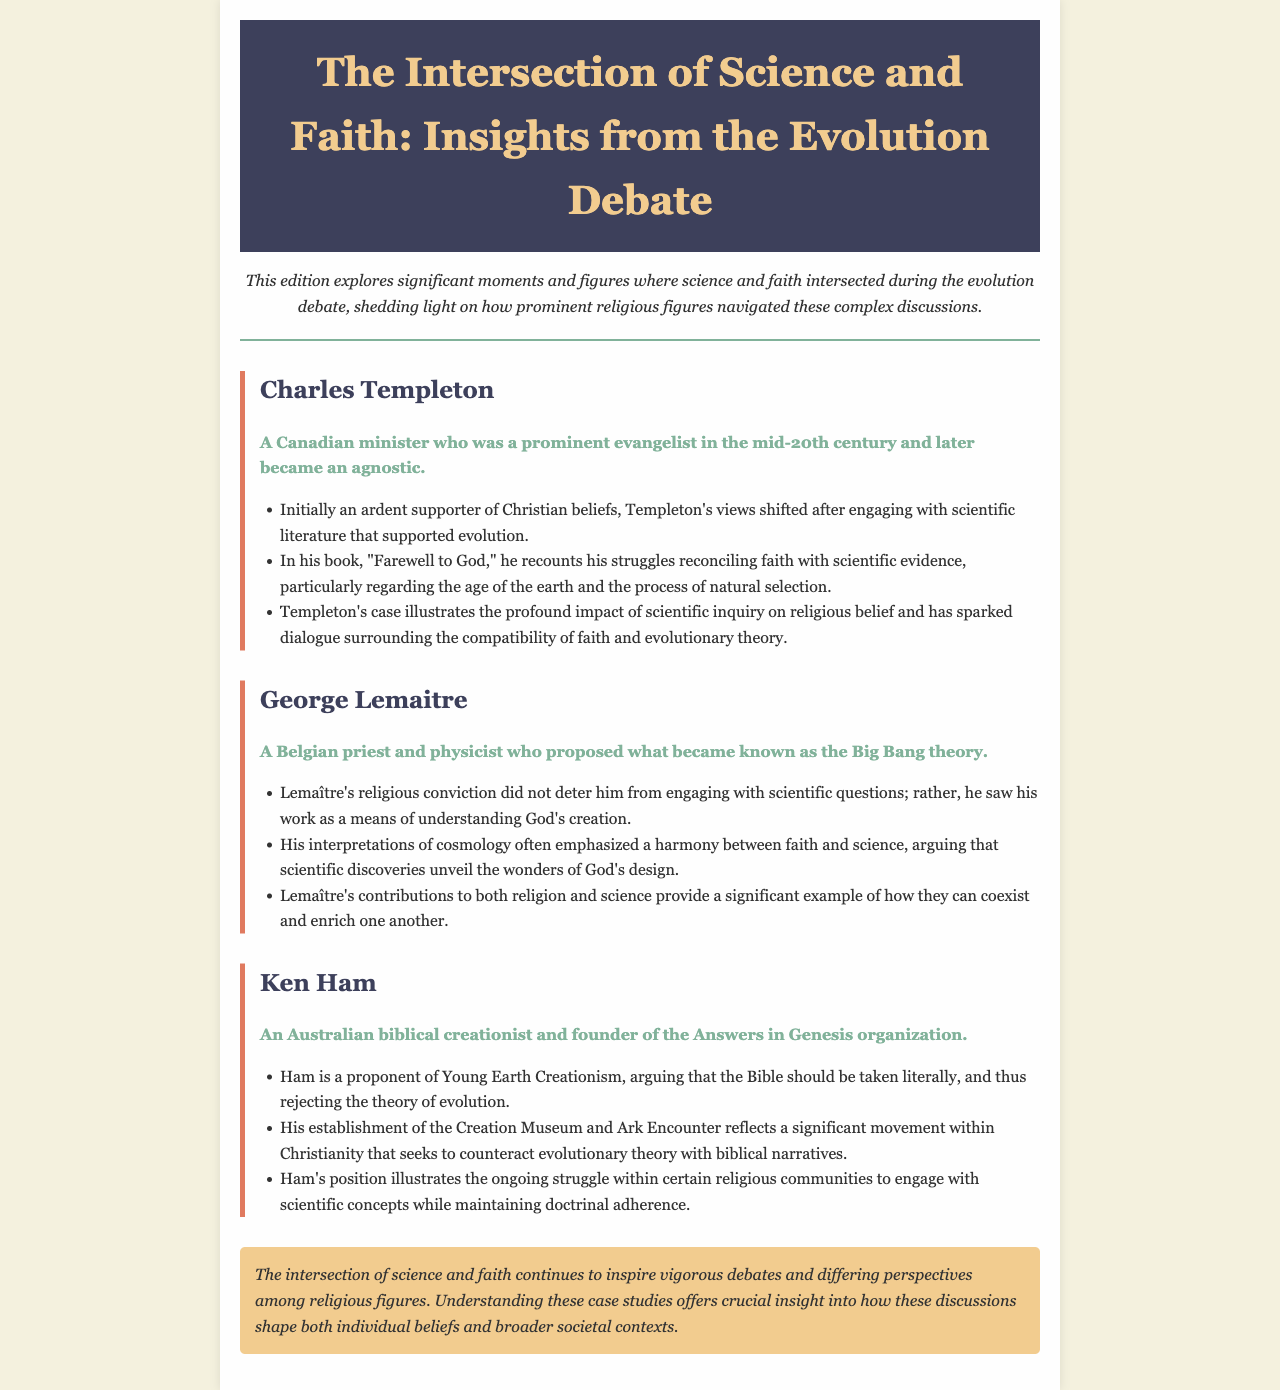What is the title of the newsletter? The title of the newsletter is prominently displayed at the top of the document.
Answer: The Intersection of Science and Faith: Insights from the Evolution Debate Who is Charles Templeton? The document provides a brief introduction to Charles Templeton, mentioning his background and beliefs.
Answer: A Canadian minister who was a prominent evangelist in the mid-20th century and later became an agnostic What is George Lemaitre known for? The document specifies Lemaitre's contributions to both faith and science, highlighting his proposal of a significant scientific theory.
Answer: The Big Bang theory What type of creationism does Ken Ham advocate? The document explicitly mentions Ham's position regarding creationism.
Answer: Young Earth Creationism What does Charles Templeton's book recount? The document summarizes Templeton's experiences regarding faith and scientific evidence.
Answer: His struggles reconciling faith with scientific evidence How does George Lemaitre view science's relationship with faith? The document describes Lemaitre's perspective on how faith and science can work together.
Answer: Harmony between faith and science What movement does Ken Ham's organization represent? The document outlines the purpose of Ham's organization and its focus on a particular narrative.
Answer: A movement within Christianity that seeks to counteract evolutionary theory What is a common theme in all three case studies presented? The document implies a significant issue that ties the case studies together regarding individual beliefs and discussions.
Answer: The intersection of science and faith 